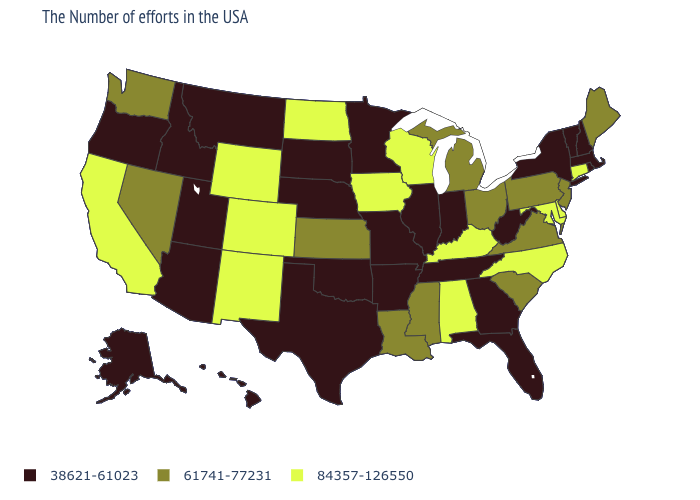How many symbols are there in the legend?
Give a very brief answer. 3. Name the states that have a value in the range 38621-61023?
Be succinct. Massachusetts, Rhode Island, New Hampshire, Vermont, New York, West Virginia, Florida, Georgia, Indiana, Tennessee, Illinois, Missouri, Arkansas, Minnesota, Nebraska, Oklahoma, Texas, South Dakota, Utah, Montana, Arizona, Idaho, Oregon, Alaska, Hawaii. Among the states that border New Mexico , does Colorado have the highest value?
Quick response, please. Yes. What is the value of New Jersey?
Answer briefly. 61741-77231. What is the value of Vermont?
Write a very short answer. 38621-61023. Among the states that border Vermont , which have the lowest value?
Give a very brief answer. Massachusetts, New Hampshire, New York. Among the states that border Ohio , which have the highest value?
Short answer required. Kentucky. Among the states that border Wisconsin , does Michigan have the lowest value?
Keep it brief. No. What is the lowest value in the MidWest?
Be succinct. 38621-61023. What is the value of Georgia?
Quick response, please. 38621-61023. Name the states that have a value in the range 38621-61023?
Write a very short answer. Massachusetts, Rhode Island, New Hampshire, Vermont, New York, West Virginia, Florida, Georgia, Indiana, Tennessee, Illinois, Missouri, Arkansas, Minnesota, Nebraska, Oklahoma, Texas, South Dakota, Utah, Montana, Arizona, Idaho, Oregon, Alaska, Hawaii. Does Arkansas have the highest value in the South?
Be succinct. No. Does Tennessee have a lower value than Mississippi?
Concise answer only. Yes. Name the states that have a value in the range 38621-61023?
Answer briefly. Massachusetts, Rhode Island, New Hampshire, Vermont, New York, West Virginia, Florida, Georgia, Indiana, Tennessee, Illinois, Missouri, Arkansas, Minnesota, Nebraska, Oklahoma, Texas, South Dakota, Utah, Montana, Arizona, Idaho, Oregon, Alaska, Hawaii. 